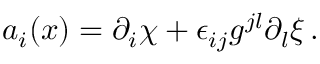Convert formula to latex. <formula><loc_0><loc_0><loc_500><loc_500>a _ { i } ( x ) = \partial _ { i } \chi + \epsilon _ { i j } g ^ { j l } \partial _ { l } \xi \, .</formula> 